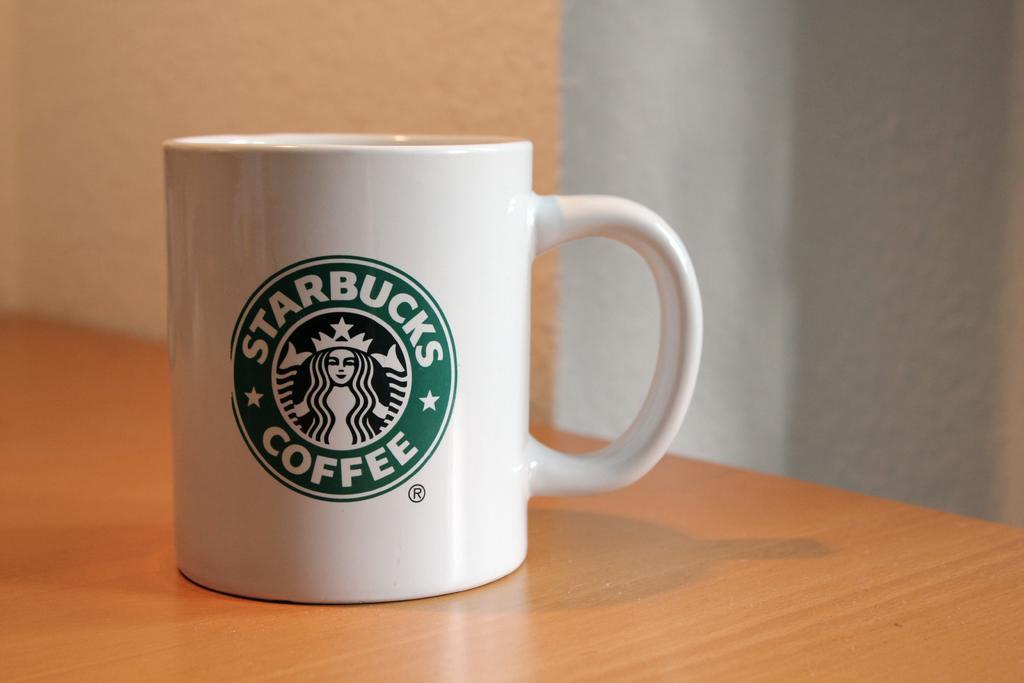Can you describe this image briefly? In the picture I can see the white color cup with a green color logo on it is placed on the wooden surface. In the background, I can see the wall. 